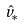Convert formula to latex. <formula><loc_0><loc_0><loc_500><loc_500>\hat { v } _ { * }</formula> 